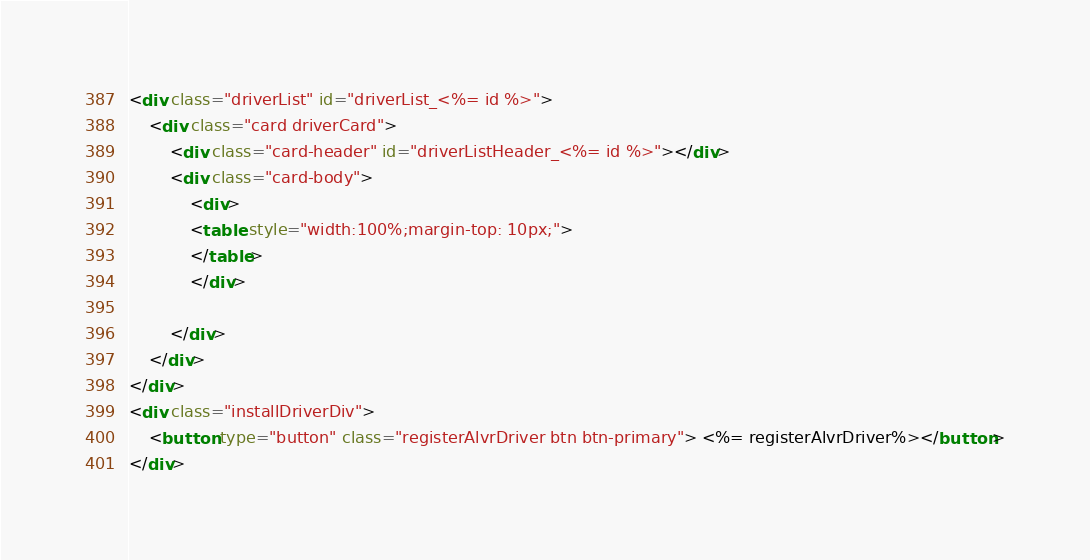Convert code to text. <code><loc_0><loc_0><loc_500><loc_500><_HTML_><div class="driverList" id="driverList_<%= id %>">
    <div class="card driverCard">
        <div class="card-header" id="driverListHeader_<%= id %>"></div>
        <div class="card-body">
            <div>
            <table style="width:100%;margin-top: 10px;">
            </table>
            </div>

        </div>
    </div>
</div>
<div class="installDriverDiv">
    <button type="button" class="registerAlvrDriver btn btn-primary"> <%= registerAlvrDriver%></button>
</div></code> 